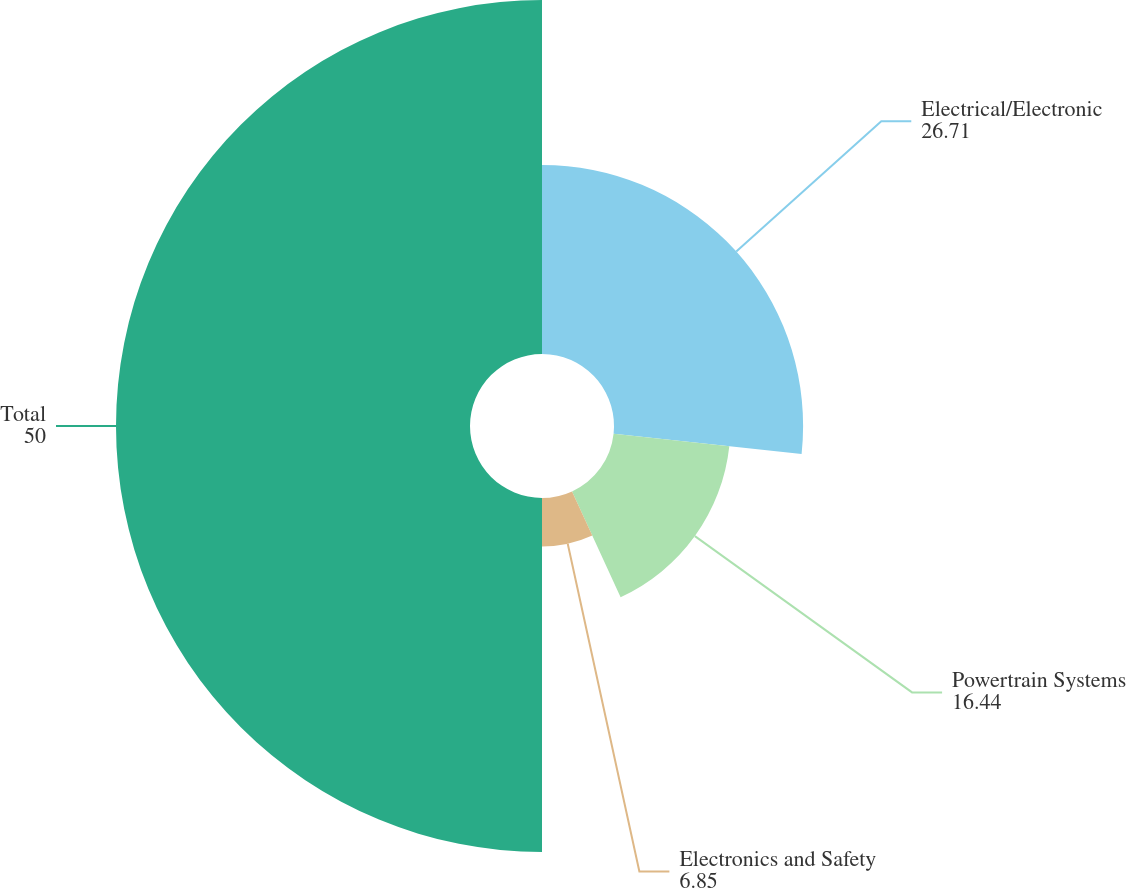Convert chart to OTSL. <chart><loc_0><loc_0><loc_500><loc_500><pie_chart><fcel>Electrical/Electronic<fcel>Powertrain Systems<fcel>Electronics and Safety<fcel>Total<nl><fcel>26.71%<fcel>16.44%<fcel>6.85%<fcel>50.0%<nl></chart> 